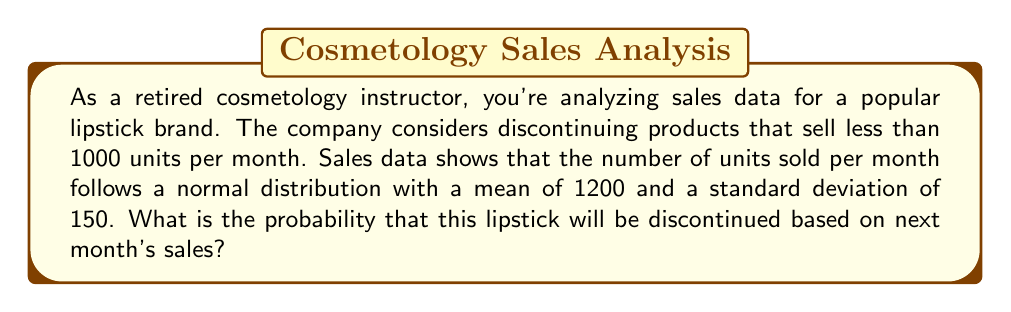What is the answer to this math problem? To solve this problem, we need to use the properties of the normal distribution and calculate the z-score for the threshold value.

1. Given information:
   - Mean (μ) = 1200 units
   - Standard deviation (σ) = 150 units
   - Threshold for discontinuation (x) = 1000 units

2. Calculate the z-score for the threshold value:
   $$ z = \frac{x - \mu}{\sigma} = \frac{1000 - 1200}{150} = -\frac{200}{150} = -1.33 $$

3. The probability of the lipstick being discontinued is equal to the probability of selling less than 1000 units, which is represented by the area under the normal curve to the left of z = -1.33.

4. Using a standard normal distribution table or a calculator, we can find that the area to the left of z = -1.33 is approximately 0.0918.

5. Therefore, the probability of the lipstick being discontinued based on next month's sales is about 0.0918 or 9.18%.
Answer: The probability that the lipstick will be discontinued based on next month's sales is approximately 0.0918 or 9.18%. 